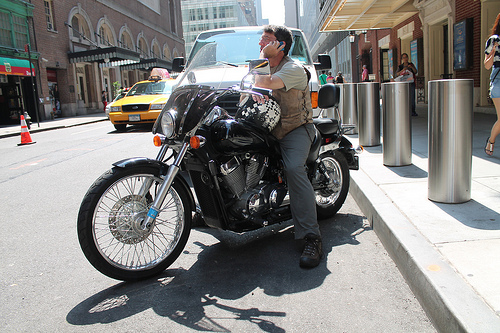On which side of the image is the cone, the right or the left? The orange cone is situated on the left-hand side of the image. 